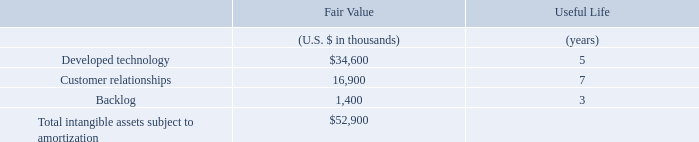The following table sets forth the components of identifiable intangible assets acquired and their estimated useful lives as of the date of acquisition.
The amount recorded for developed technology represents the estimated fair value of AgileCraft’s enterprise agile planning technology. The amount recorded for customer relationships represents the fair value of the underlying relationships with AgileCraft’s customers. The amount recorded for backlog represents the fair value of AgileCraft’s backlog as of acquisition date.
What does the amount recorded for developed technology represent? The estimated fair value of agilecraft’s enterprise agile planning technology. What does the amount recorded for customer relationships represent? The fair value of the underlying relationships with agilecraft’s customers. What is the useful life of  Developed technology in years? 5. What is the difference in fair value between developed technology and customer relationships?
Answer scale should be: thousand. 34,600-16,900
Answer: 17700. What are the identifiable intangible assets with a useful life above 5 years? For COL 4 rows 3-5 check if value is >5 . If value is >5 input corresponding identifiable intangible assets in COL2 as answer
Answer: customer relationships. For fair value, what is the percentage constitution of customer relationships among the total intangible assets subject to amortization?
Answer scale should be: percent. 16,900/52,900
Answer: 31.95. 